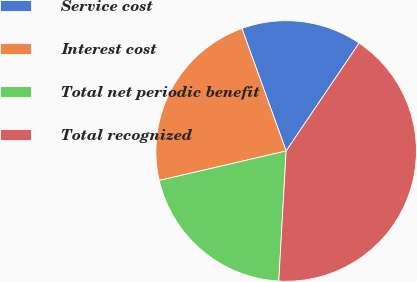Convert chart to OTSL. <chart><loc_0><loc_0><loc_500><loc_500><pie_chart><fcel>Service cost<fcel>Interest cost<fcel>Total net periodic benefit<fcel>Total recognized<nl><fcel>14.98%<fcel>23.12%<fcel>20.47%<fcel>41.44%<nl></chart> 